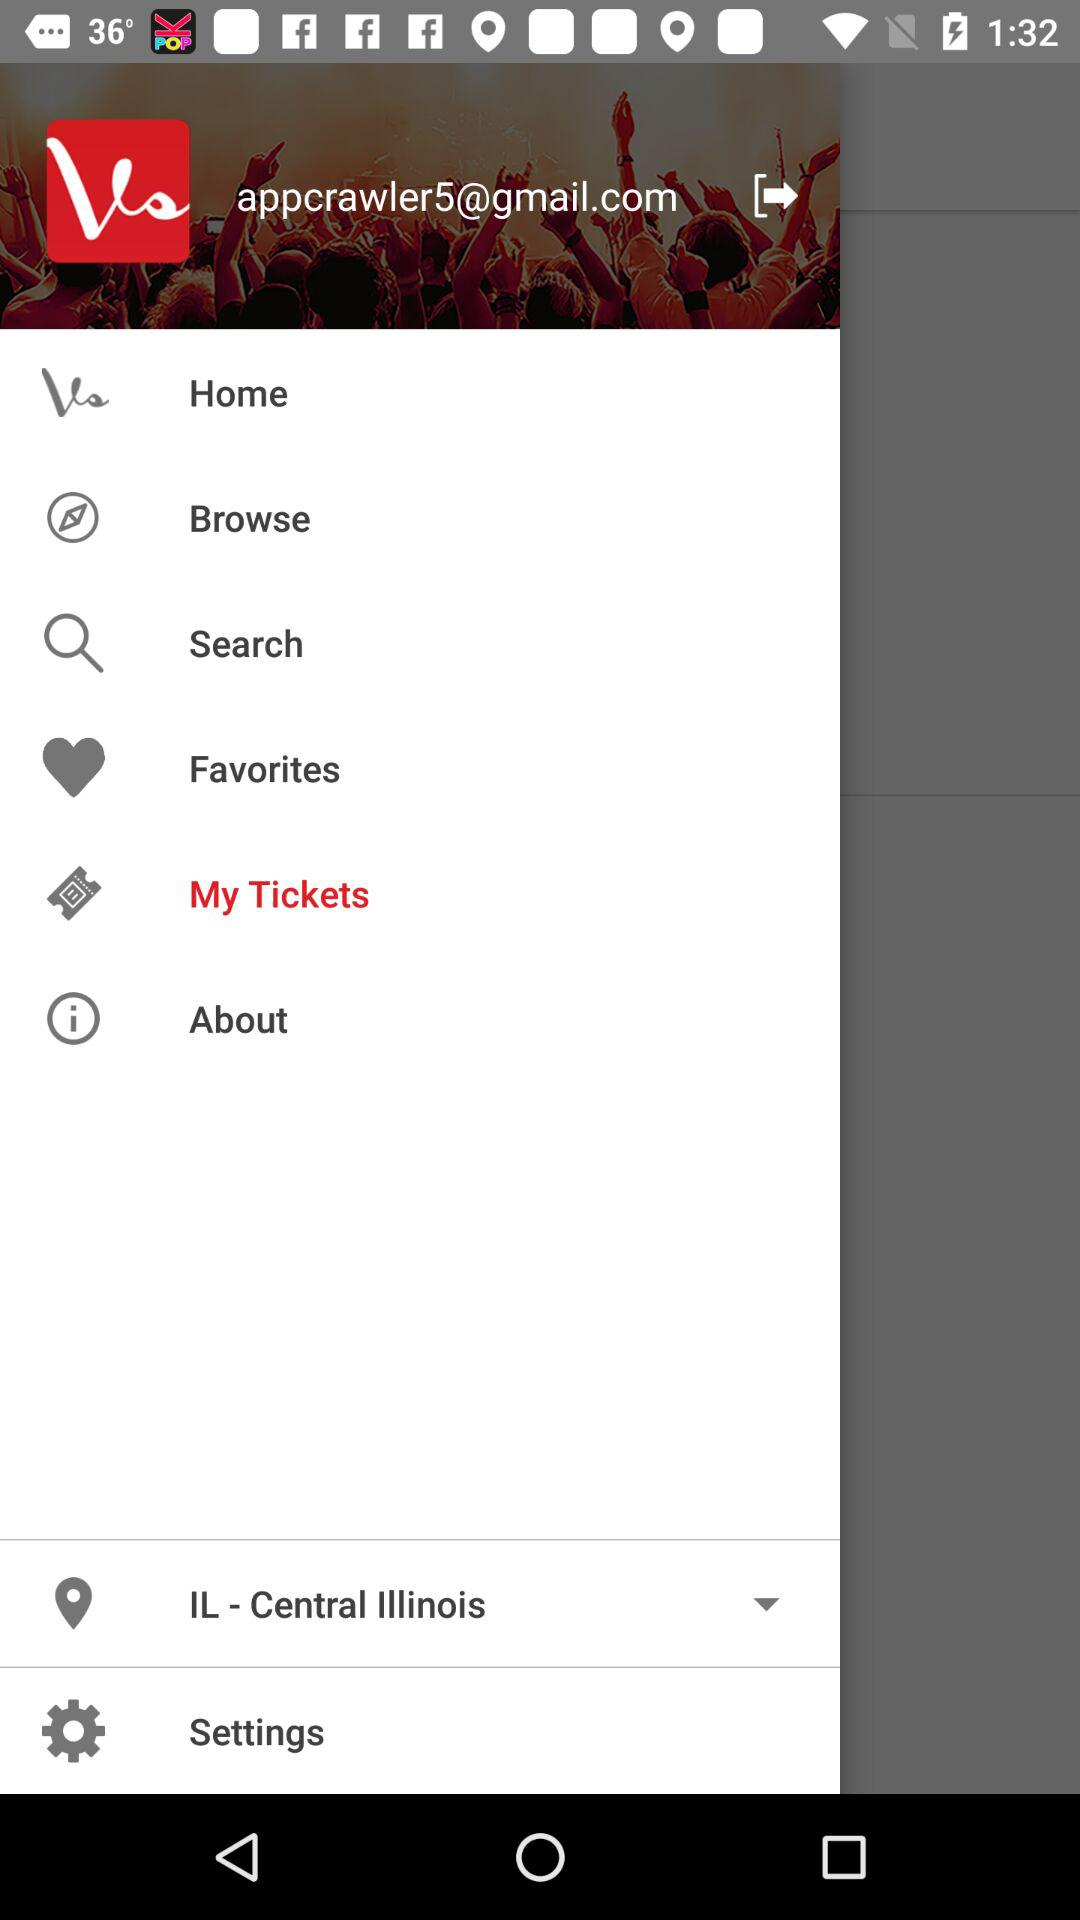What is the name of the application? The name of the application is "Vivid Seats". 